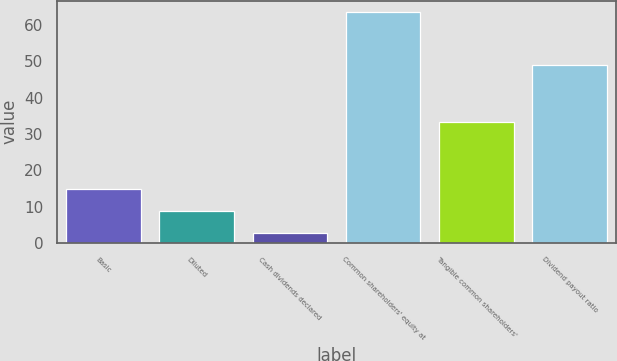Convert chart to OTSL. <chart><loc_0><loc_0><loc_500><loc_500><bar_chart><fcel>Basic<fcel>Diluted<fcel>Cash dividends declared<fcel>Common shareholders' equity at<fcel>Tangible common shareholders'<fcel>Dividend payout ratio<nl><fcel>14.94<fcel>8.87<fcel>2.8<fcel>63.54<fcel>33.26<fcel>48.98<nl></chart> 